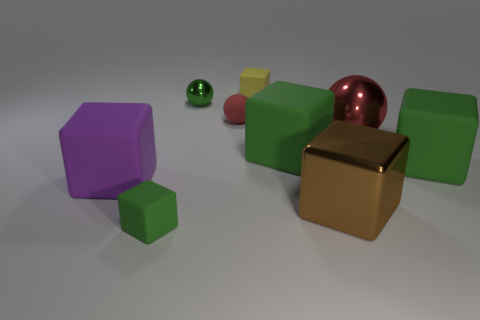Subtract all green cubes. How many were subtracted if there are1green cubes left? 2 Subtract all yellow rubber cubes. How many cubes are left? 5 Subtract all green balls. How many balls are left? 2 Add 1 purple rubber things. How many objects exist? 10 Subtract all balls. How many objects are left? 6 Subtract 1 blocks. How many blocks are left? 5 Subtract all red blocks. How many green balls are left? 1 Add 5 green matte blocks. How many green matte blocks are left? 8 Add 3 brown metal cubes. How many brown metal cubes exist? 4 Subtract 0 green cylinders. How many objects are left? 9 